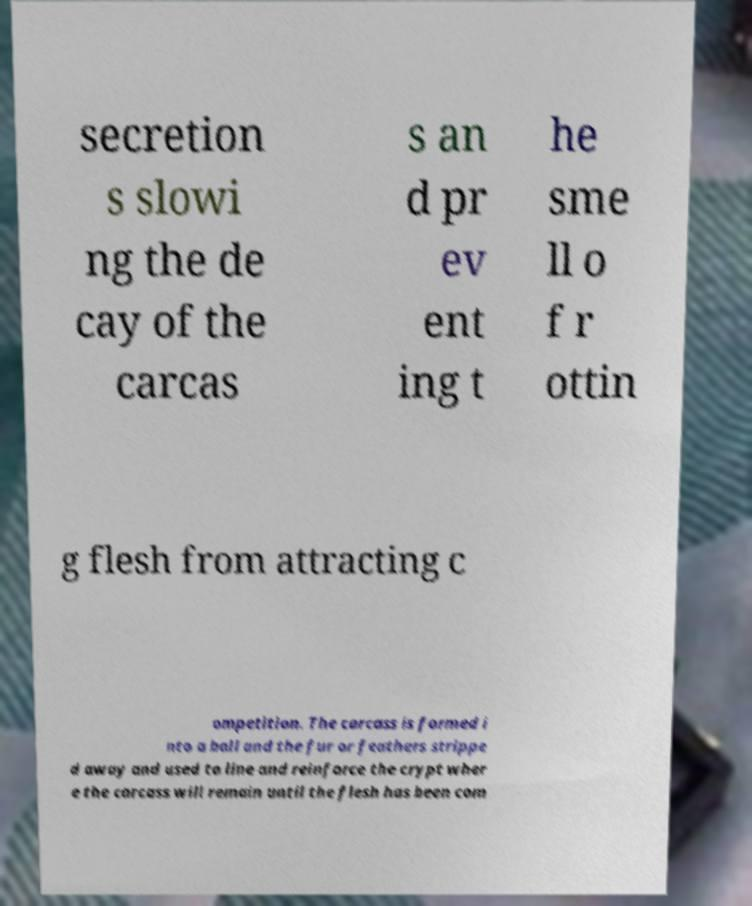Can you read and provide the text displayed in the image?This photo seems to have some interesting text. Can you extract and type it out for me? secretion s slowi ng the de cay of the carcas s an d pr ev ent ing t he sme ll o f r ottin g flesh from attracting c ompetition. The carcass is formed i nto a ball and the fur or feathers strippe d away and used to line and reinforce the crypt wher e the carcass will remain until the flesh has been com 